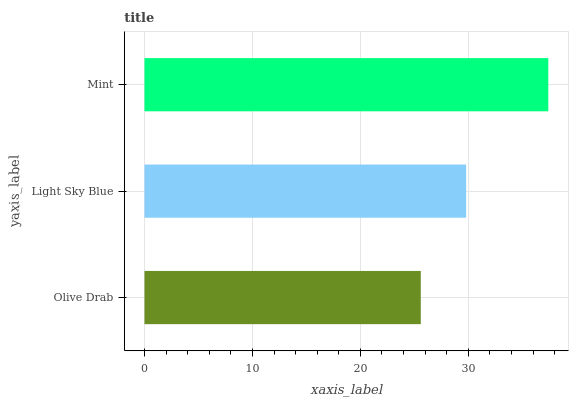Is Olive Drab the minimum?
Answer yes or no. Yes. Is Mint the maximum?
Answer yes or no. Yes. Is Light Sky Blue the minimum?
Answer yes or no. No. Is Light Sky Blue the maximum?
Answer yes or no. No. Is Light Sky Blue greater than Olive Drab?
Answer yes or no. Yes. Is Olive Drab less than Light Sky Blue?
Answer yes or no. Yes. Is Olive Drab greater than Light Sky Blue?
Answer yes or no. No. Is Light Sky Blue less than Olive Drab?
Answer yes or no. No. Is Light Sky Blue the high median?
Answer yes or no. Yes. Is Light Sky Blue the low median?
Answer yes or no. Yes. Is Olive Drab the high median?
Answer yes or no. No. Is Mint the low median?
Answer yes or no. No. 